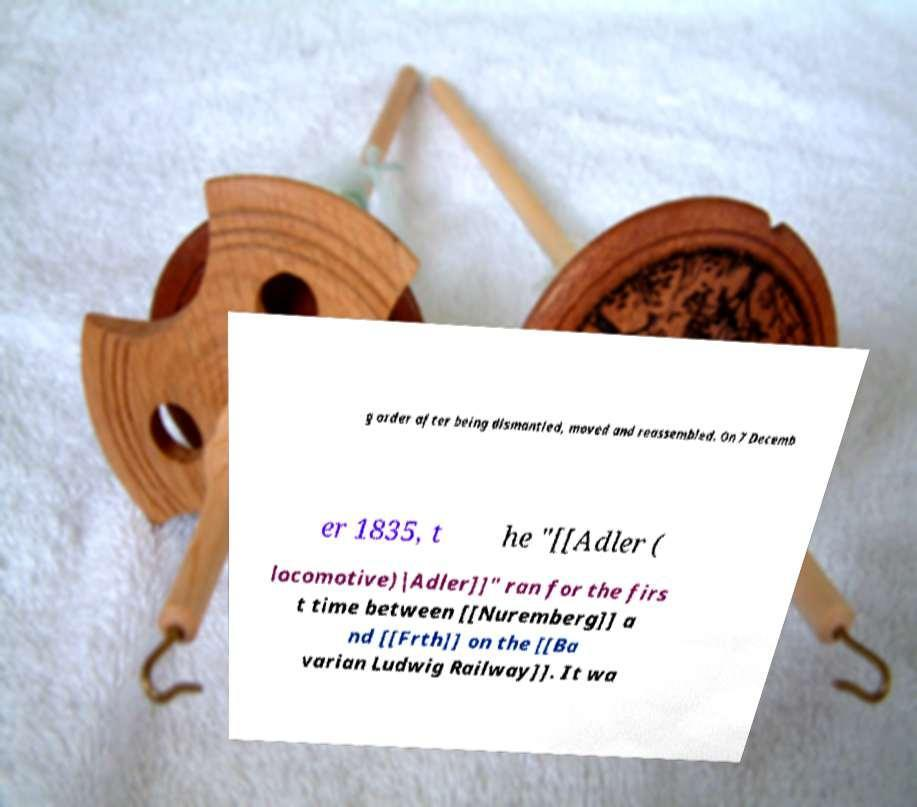Can you accurately transcribe the text from the provided image for me? g order after being dismantled, moved and reassembled. On 7 Decemb er 1835, t he "[[Adler ( locomotive)|Adler]]" ran for the firs t time between [[Nuremberg]] a nd [[Frth]] on the [[Ba varian Ludwig Railway]]. It wa 